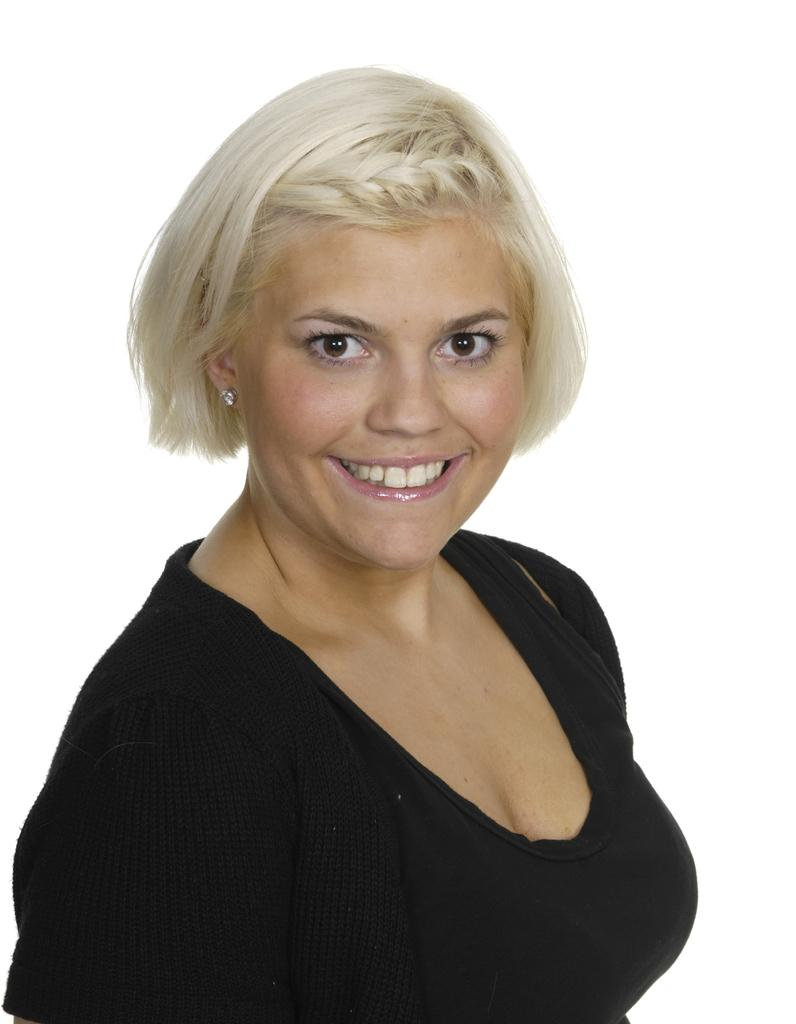What is the main subject of the image? The main subject of the image is a woman. What is the woman wearing in the image? The woman is wearing a black dress. What expression does the woman have on her face? The woman is showing her teeth, which suggests she might be smiling. Who is the owner of the vegetable farm in the image? There is no vegetable farm or owner mentioned or depicted in the image. Is the woman in the image using a plough? There is no plough or any indication of farming activities in the image. 